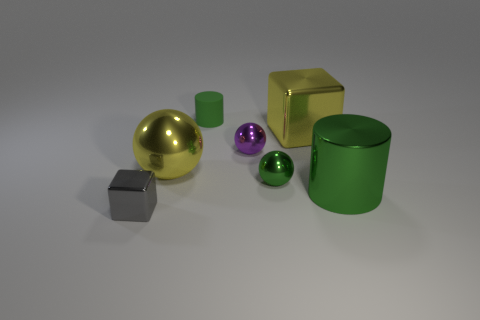Is the tiny rubber object the same shape as the purple thing?
Provide a short and direct response. No. What is the material of the yellow object that is the same shape as the small purple thing?
Give a very brief answer. Metal. What number of matte cylinders have the same color as the large block?
Your response must be concise. 0. What is the size of the other cube that is made of the same material as the small gray cube?
Offer a very short reply. Large. What number of brown objects are either shiny spheres or big cylinders?
Your answer should be very brief. 0. There is a tiny metallic sphere left of the tiny green metallic thing; what number of yellow objects are behind it?
Your answer should be compact. 1. Is the number of spheres behind the tiny green metallic ball greater than the number of tiny balls that are in front of the gray thing?
Your answer should be very brief. Yes. What material is the gray block?
Give a very brief answer. Metal. Is there a matte cylinder of the same size as the purple thing?
Provide a short and direct response. Yes. There is a yellow block that is the same size as the shiny cylinder; what material is it?
Keep it short and to the point. Metal. 